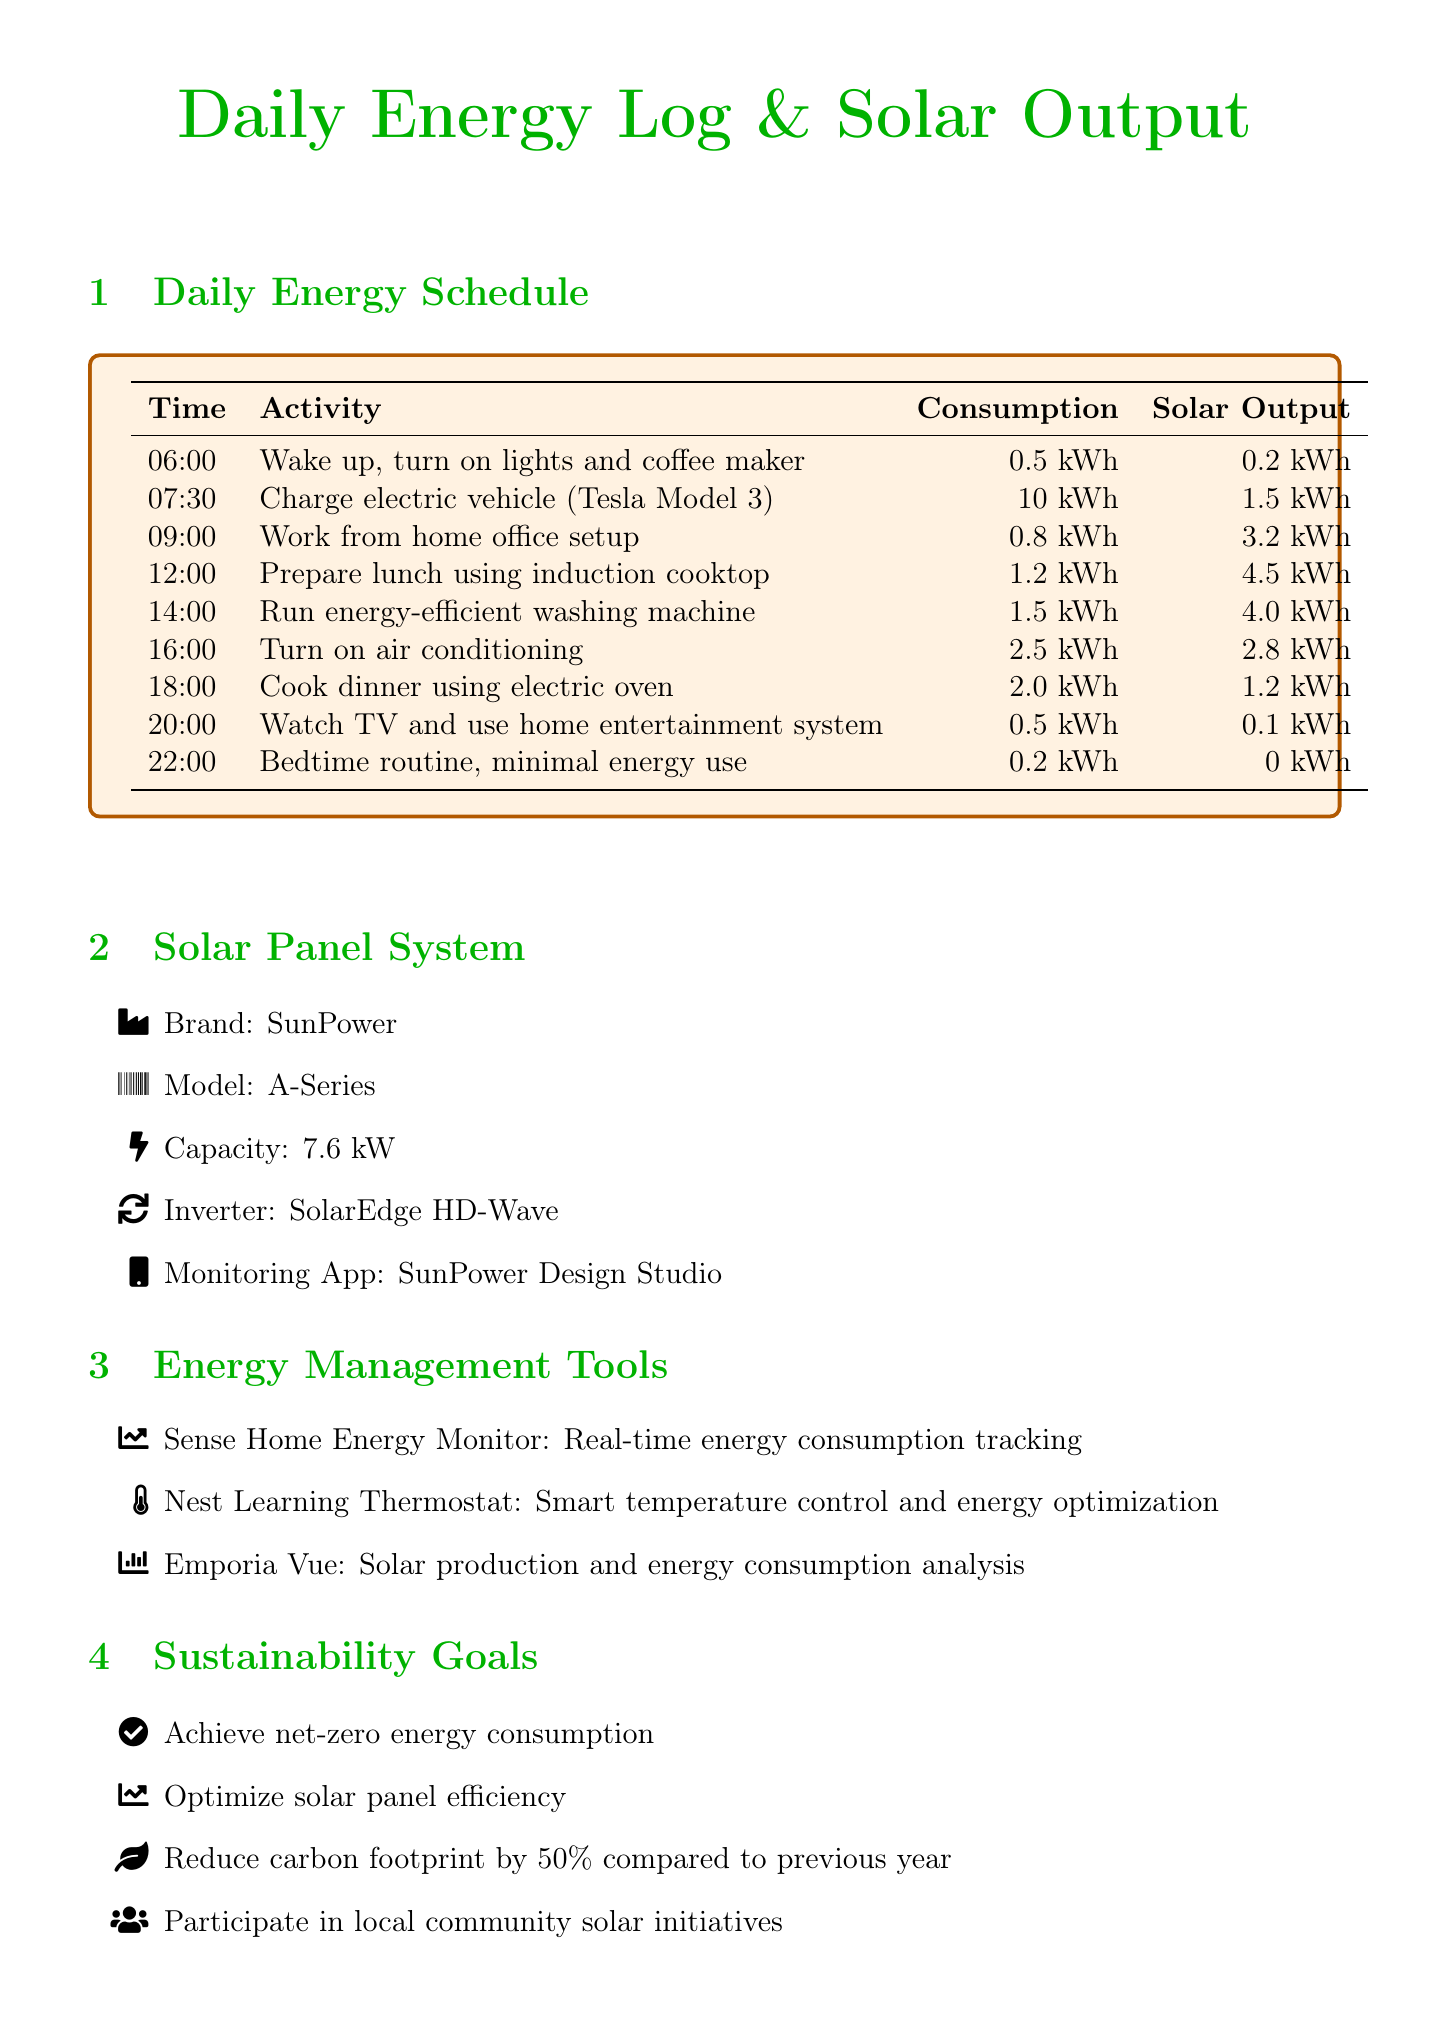what time does the bed routine start? The bedtime routine begins at 22:00 according to the daily energy schedule.
Answer: 22:00 how much energy is consumed during lunch preparation? The consumption during lunch preparation using the induction cooktop is documented to be 1.2 kWh.
Answer: 1.2 kWh what is the capacity of the solar panel system? The capacity of the solar panel system is specifically mentioned as 7.6 kW.
Answer: 7.6 kW what activity occurs at 14:00? At 14:00, the activity recorded is running the energy-efficient washing machine.
Answer: Run energy-efficient washing machine how much solar output is generated at 09:00? The solar output recorded at 09:00 is noted as 3.2 kWh.
Answer: 3.2 kWh what is one of the sustainability goals? One of the sustainability goals listed is to achieve net-zero energy consumption.
Answer: Achieve net-zero energy consumption how much energy does the electric vehicle charging use? The electric vehicle charging consumes 10 kWh based on the log activity data.
Answer: 10 kWh which energy management tool is used for real-time energy tracking? The Sense Home Energy Monitor is the tool mentioned for real-time energy tracking.
Answer: Sense Home Energy Monitor what sustainability tip is provided for cooking? The tip provided for cooking is to use lids on pots to reduce cooking time and energy use.
Answer: Use lids on pots to reduce cooking time and energy use 